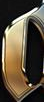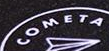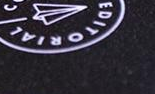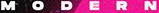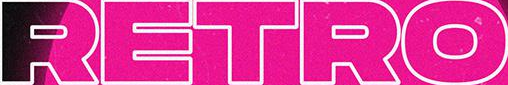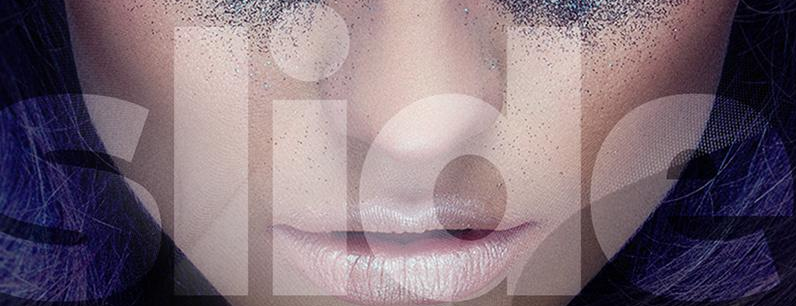Read the text from these images in sequence, separated by a semicolon. #; COMETA; EDITORIAL; MODERN; RETRO; slide 